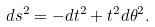Convert formula to latex. <formula><loc_0><loc_0><loc_500><loc_500>d s ^ { 2 } = - d t ^ { 2 } + t ^ { 2 } d \theta ^ { 2 } .</formula> 